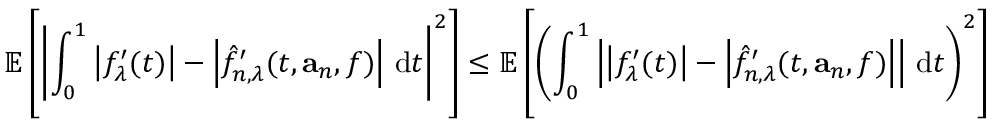<formula> <loc_0><loc_0><loc_500><loc_500>\mathbb { E } \left [ \left | \int _ { 0 } ^ { 1 } \left | f _ { \lambda } ^ { \prime } ( t ) \right | - \left | \hat { f } _ { n , \lambda } ^ { \prime } ( t , a _ { n } , f ) \right | \, d t \right | ^ { 2 } \right ] \leq \mathbb { E } \left [ \left ( \int _ { 0 } ^ { 1 } \left | \left | f _ { \lambda } ^ { \prime } ( t ) \right | - \left | \hat { f } _ { n , \lambda } ^ { \prime } ( t , a _ { n } , f ) \right | \right | \, d t \right ) ^ { 2 } \right ]</formula> 